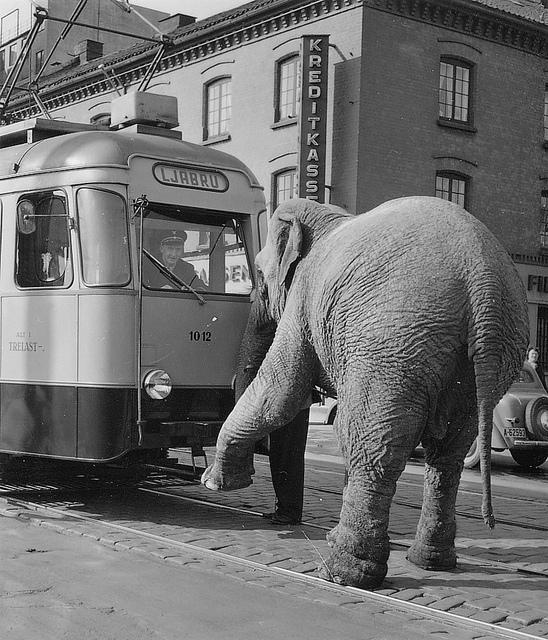Is the train steam powered?
Answer briefly. No. Is the elephant going to get hurt?
Short answer required. No. Is the elephant wearing a costume?
Short answer required. No. What animal is this?
Be succinct. Elephant. What is the elephant pushing?
Write a very short answer. Train. What is this elephant doing?
Keep it brief. Walking. What is the color of the car?
Quick response, please. Gray. 